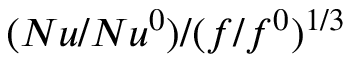<formula> <loc_0><loc_0><loc_500><loc_500>( N u / N u ^ { 0 } ) / ( f / f ^ { 0 } ) ^ { 1 / 3 }</formula> 